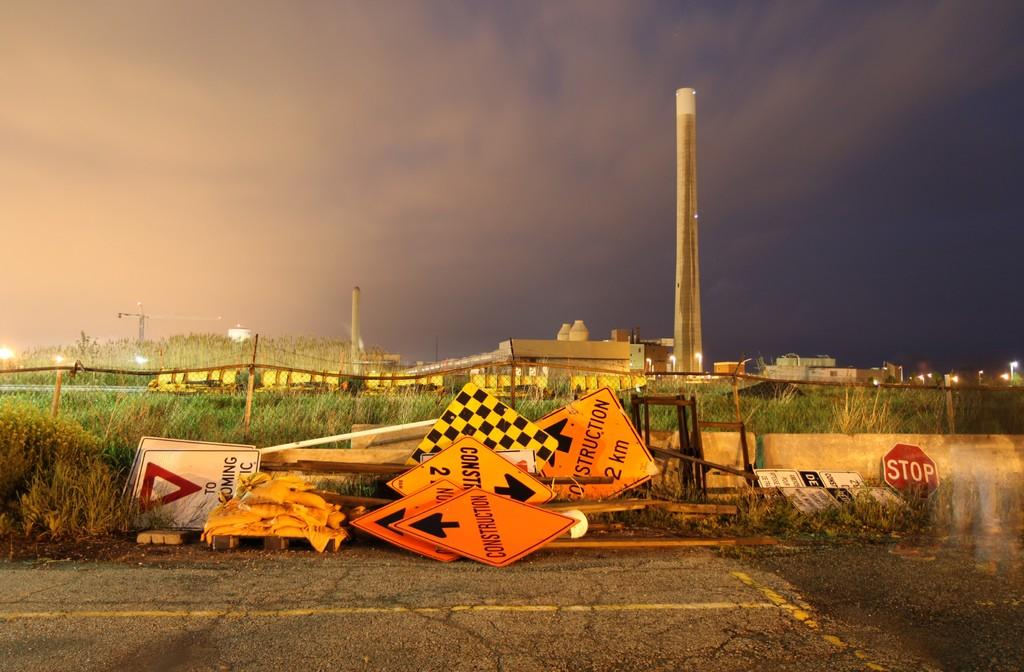<image>
Render a clear and concise summary of the photo. Multiple constructions signs, stop signs, and construction 2km signs. 